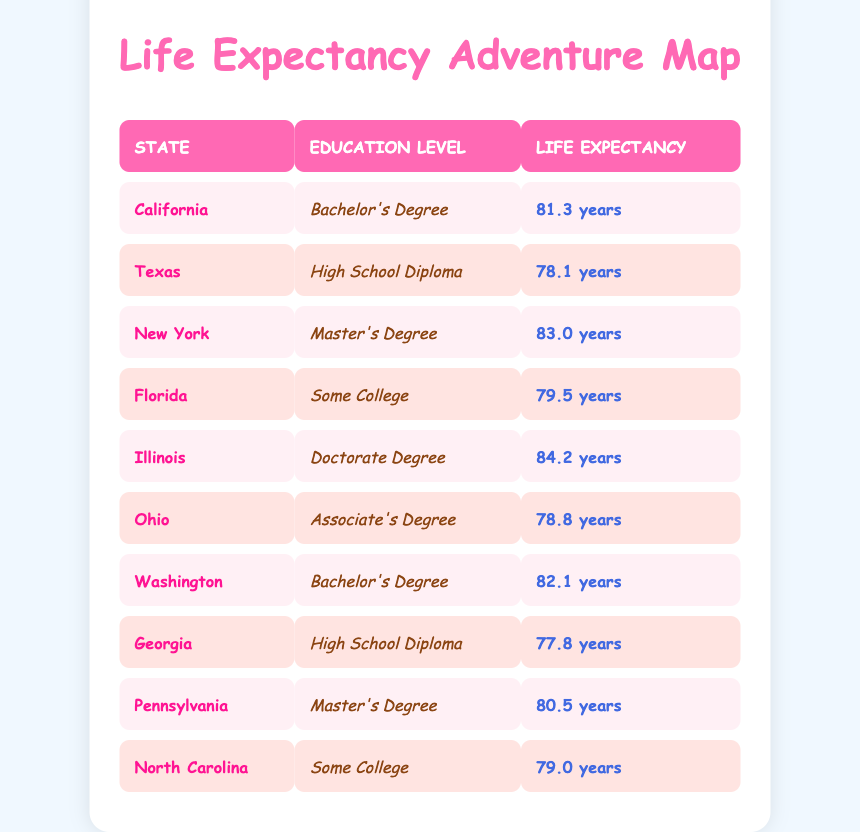What is the life expectancy for individuals with a Master's Degree in New York? The table lists New York under the "Master's Degree" education level with a life expectancy of 83.0 years.
Answer: 83.0 years Which state has the highest life expectancy and what is that value? According to the table, Illinois has the highest life expectancy at 84.2 years.
Answer: 84.2 years Is the life expectancy for those with a Bachelor's Degree in California higher than that of someone with an Associate's Degree in Ohio? In California, the life expectancy for a Bachelor's Degree is 81.3 years, while in Ohio, it is 78.8 years for an Associate's Degree. Since 81.3 is greater than 78.8, the statement is true.
Answer: Yes What is the average life expectancy for individuals with a High School Diploma? The table shows two states with High School Diploma: Texas (78.1 years) and Georgia (77.8 years). To find the average, we sum the values (78.1 + 77.8) totaling 155.9 years and then divide by the number of states (2). Thus, the average is 155.9/2 = 77.95 years.
Answer: 77.95 years Do people with a Doctorate Degree have a higher life expectancy than those with Some College education? The life expectancy for individuals with a Doctorate Degree in Illinois is 84.2 years, while the life expectancy for Some College individuals in Florida is 79.5 years. Since 84.2 is greater than 79.5, the statement is true.
Answer: Yes Which education level associated with Florida has a higher life expectancy than the education level in Georgia? Florida has individuals with "Some College" and a life expectancy of 79.5 years, while Georgia has "High School Diploma" with 77.8 years. Since 79.5 is greater than 77.8, we can conclude that Some College in Florida has a higher life expectancy than High School Diploma in Georgia.
Answer: Yes What is the difference in life expectancy between individuals with a Master's Degree and those with a Bachelor's Degree? The life expectancy for a Master's Degree in New York is 83.0 years and for a Bachelor's Degree in California is 81.3 years. The difference is 83.0 - 81.3 = 1.7 years.
Answer: 1.7 years How many states are listed with a life expectancy of less than 80 years? The states with life expectancies below 80 years are Texas (78.1), Georgia (77.8), and Ohio (78.8), totaling three states.
Answer: 3 states 